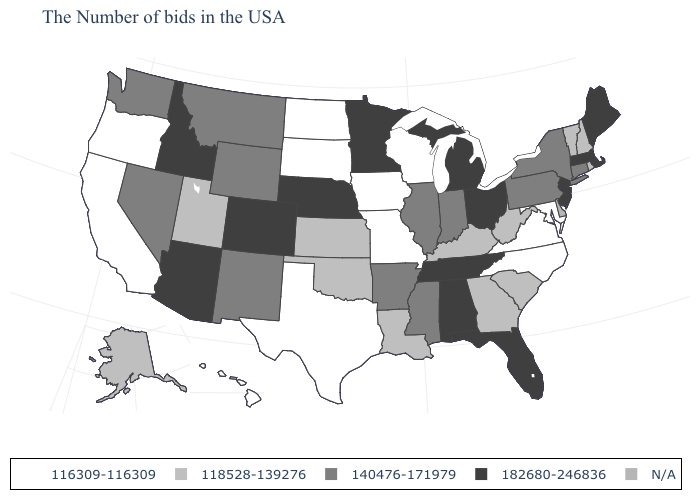What is the value of Ohio?
Concise answer only. 182680-246836. Does the first symbol in the legend represent the smallest category?
Write a very short answer. Yes. Does Connecticut have the lowest value in the USA?
Short answer required. No. What is the value of Missouri?
Give a very brief answer. 116309-116309. Does the first symbol in the legend represent the smallest category?
Answer briefly. Yes. Name the states that have a value in the range 116309-116309?
Concise answer only. Maryland, Virginia, North Carolina, Wisconsin, Missouri, Iowa, Texas, South Dakota, North Dakota, California, Oregon, Hawaii. Which states hav the highest value in the Northeast?
Be succinct. Maine, Massachusetts, New Jersey. Name the states that have a value in the range N/A?
Give a very brief answer. Delaware. Does Alabama have the highest value in the South?
Short answer required. Yes. Among the states that border Texas , does Oklahoma have the lowest value?
Keep it brief. Yes. Among the states that border Oklahoma , does Colorado have the lowest value?
Be succinct. No. Among the states that border Georgia , which have the highest value?
Short answer required. Florida, Alabama, Tennessee. What is the lowest value in the USA?
Be succinct. 116309-116309. 